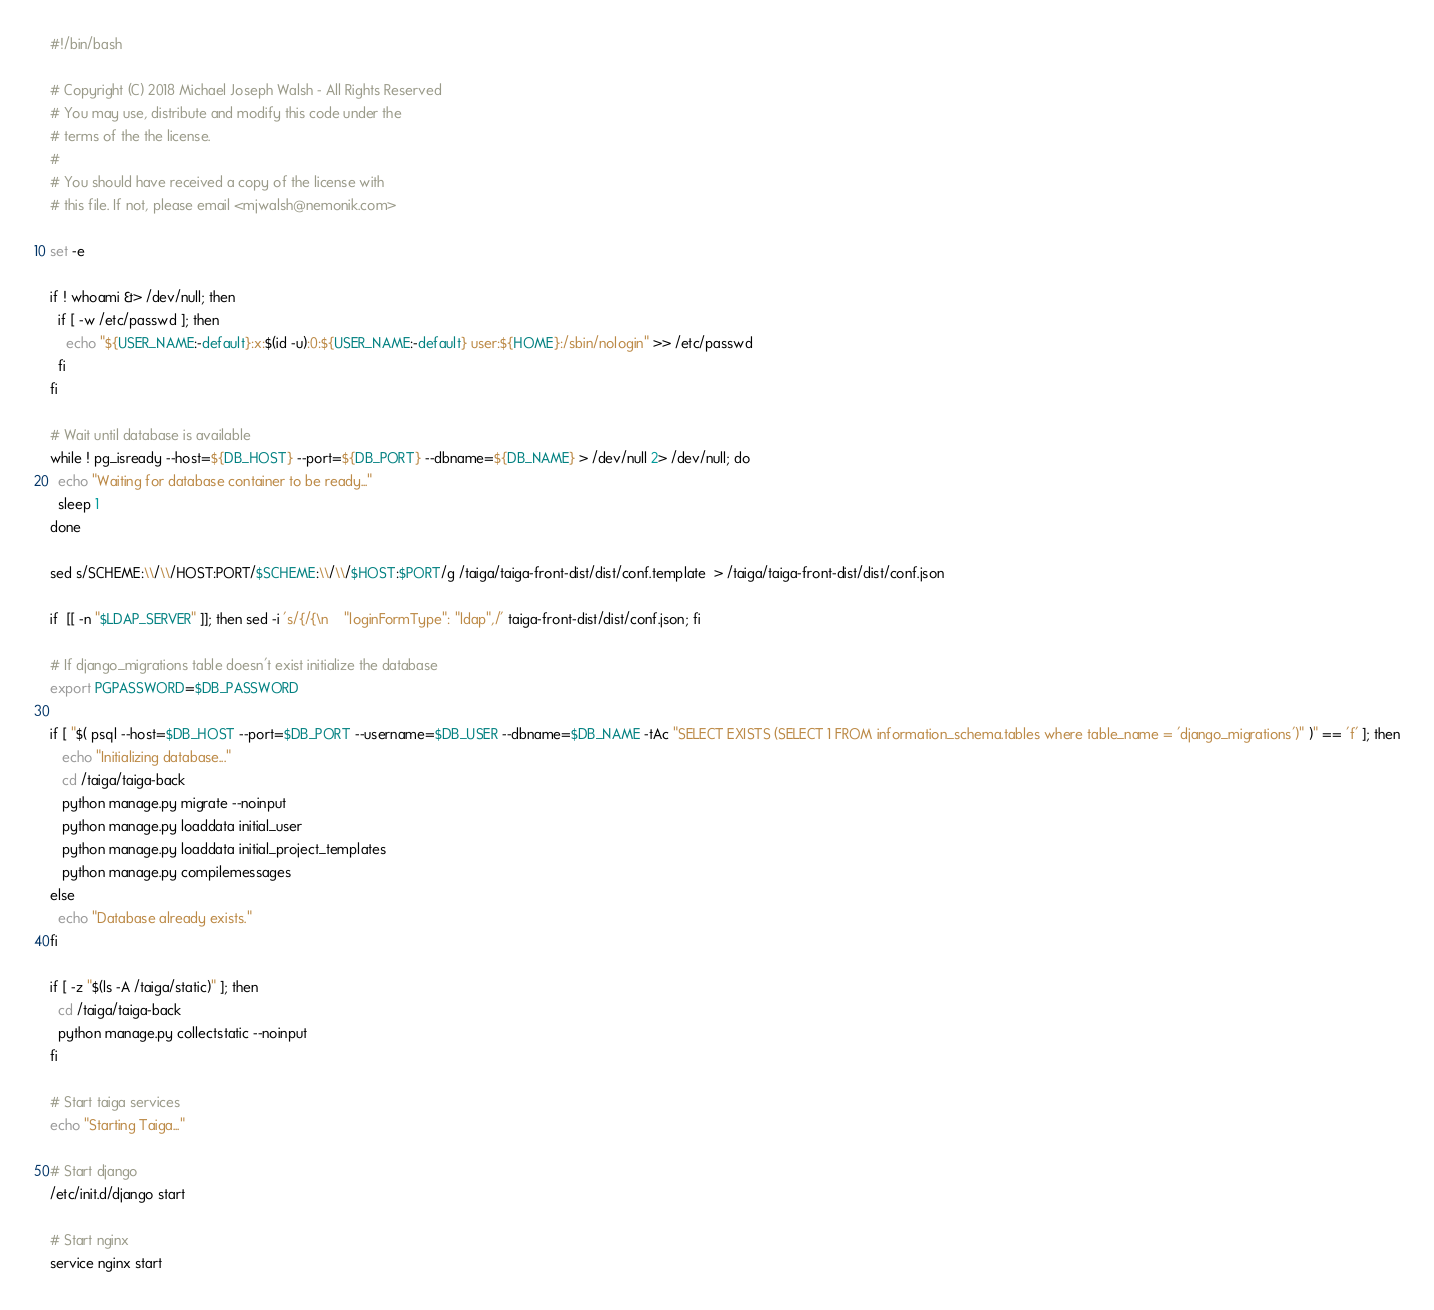<code> <loc_0><loc_0><loc_500><loc_500><_Bash_>#!/bin/bash

# Copyright (C) 2018 Michael Joseph Walsh - All Rights Reserved
# You may use, distribute and modify this code under the
# terms of the the license.
#
# You should have received a copy of the license with
# this file. If not, please email <mjwalsh@nemonik.com>

set -e

if ! whoami &> /dev/null; then
  if [ -w /etc/passwd ]; then
    echo "${USER_NAME:-default}:x:$(id -u):0:${USER_NAME:-default} user:${HOME}:/sbin/nologin" >> /etc/passwd
  fi
fi

# Wait until database is available
while ! pg_isready --host=${DB_HOST} --port=${DB_PORT} --dbname=${DB_NAME} > /dev/null 2> /dev/null; do
  echo "Waiting for database container to be ready..."
  sleep 1
done

sed s/SCHEME:\\/\\/HOST:PORT/$SCHEME:\\/\\/$HOST:$PORT/g /taiga/taiga-front-dist/dist/conf.template  > /taiga/taiga-front-dist/dist/conf.json

if  [[ -n "$LDAP_SERVER" ]]; then sed -i 's/{/{\n    "loginFormType": "ldap",/' taiga-front-dist/dist/conf.json; fi

# If django_migrations table doesn't exist initialize the database
export PGPASSWORD=$DB_PASSWORD

if [ "$( psql --host=$DB_HOST --port=$DB_PORT --username=$DB_USER --dbname=$DB_NAME -tAc "SELECT EXISTS (SELECT 1 FROM information_schema.tables where table_name = 'django_migrations')" )" == 'f' ]; then
   echo "Initializing database..."
   cd /taiga/taiga-back
   python manage.py migrate --noinput
   python manage.py loaddata initial_user
   python manage.py loaddata initial_project_templates
   python manage.py compilemessages
else
  echo "Database already exists."
fi

if [ -z "$(ls -A /taiga/static)" ]; then
  cd /taiga/taiga-back
  python manage.py collectstatic --noinput
fi

# Start taiga services
echo "Starting Taiga..."

# Start django
/etc/init.d/django start

# Start nginx
service nginx start
</code> 